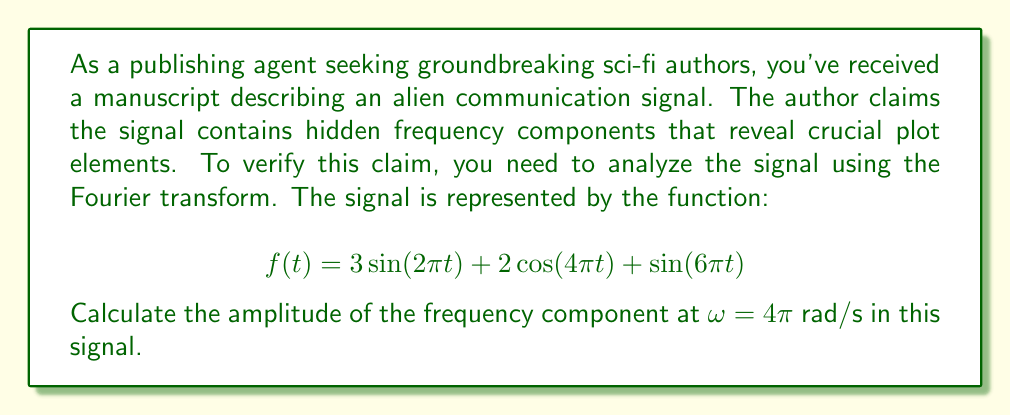Show me your answer to this math problem. To analyze the frequency components of the given signal, we need to apply the Fourier transform. The Fourier transform converts a time-domain signal into its frequency-domain representation.

Given the signal:
$$f(t) = 3\sin(2\pi t) + 2\cos(4\pi t) + \sin(6\pi t)$$

We can rewrite this using Euler's formula:
$$\sin(\omega t) = \frac{e^{i\omega t} - e^{-i\omega t}}{2i}$$
$$\cos(\omega t) = \frac{e^{i\omega t} + e^{-i\omega t}}{2}$$

Substituting these in:

$$f(t) = 3\left(\frac{e^{i2\pi t} - e^{-i2\pi t}}{2i}\right) + 2\left(\frac{e^{i4\pi t} + e^{-i4\pi t}}{2}\right) + \left(\frac{e^{i6\pi t} - e^{-i6\pi t}}{2i}\right)$$

The Fourier transform of $e^{i\omega t}$ is a delta function $2\pi\delta(\omega - \omega_0)$, where $\omega_0$ is the frequency of the exponential.

Therefore, the Fourier transform of $f(t)$ will have components at $\omega = \pm 2\pi, \pm 4\pi, \pm 6\pi$ rad/s.

The amplitude of each component is determined by the coefficient of the corresponding term in the time-domain signal.

For $\omega = 4\pi$ rad/s, the relevant term is $2\cos(4\pi t)$. The amplitude of this component is 2.
Answer: The amplitude of the frequency component at $\omega = 4\pi$ rad/s is 2. 